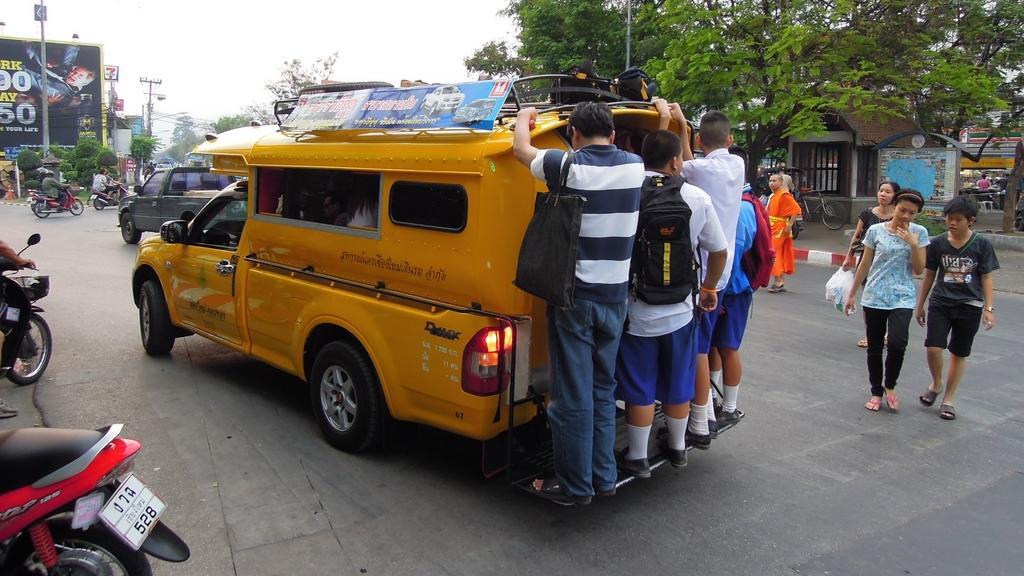Can you describe this image briefly? I can see in this image a vehicle with a couple of people standing on it. I can also see there are few people are walking on the road and few people are riding vehicles on the road. In the background I can see a advertisement hoarding, a pole and a couple of trees. 